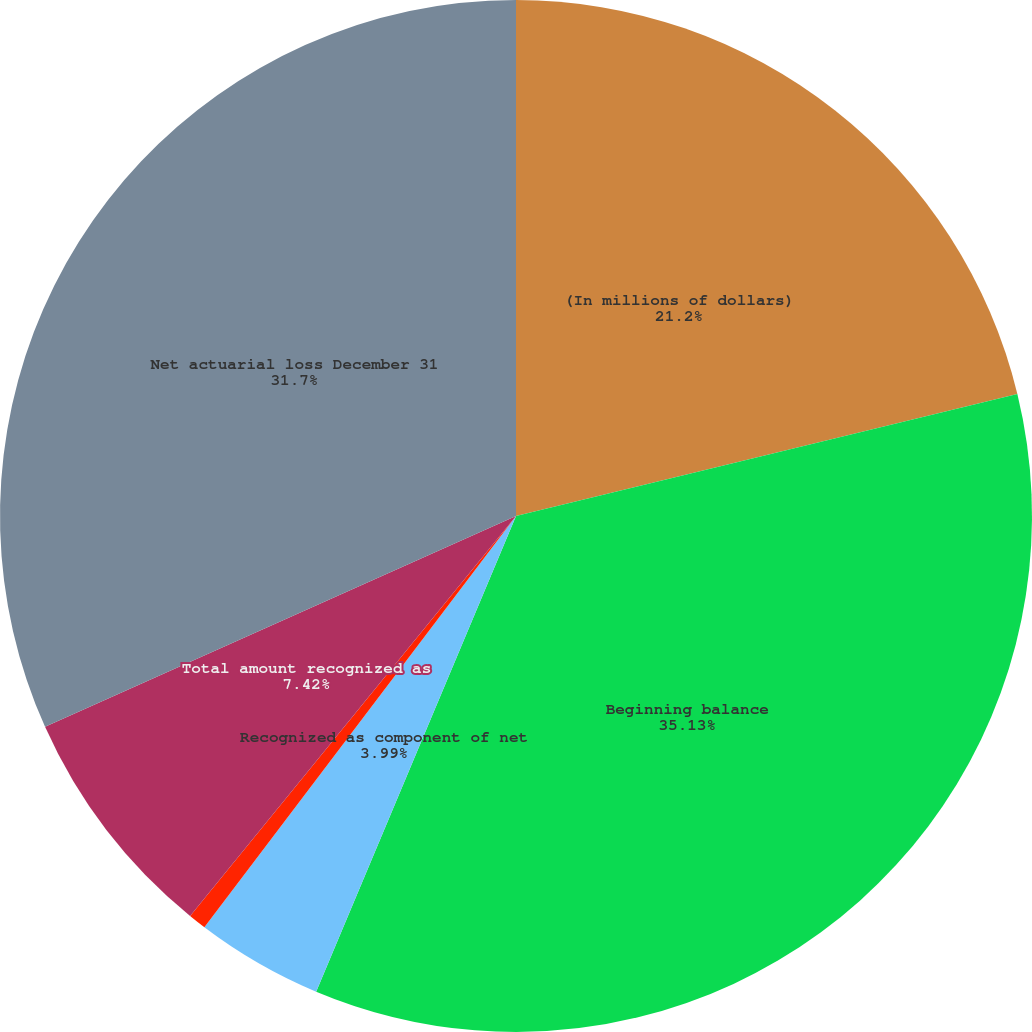<chart> <loc_0><loc_0><loc_500><loc_500><pie_chart><fcel>(In millions of dollars)<fcel>Beginning balance<fcel>Recognized as component of net<fcel>Liability experience<fcel>Total amount recognized as<fcel>Net actuarial loss December 31<nl><fcel>21.2%<fcel>35.13%<fcel>3.99%<fcel>0.56%<fcel>7.42%<fcel>31.7%<nl></chart> 